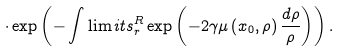<formula> <loc_0><loc_0><loc_500><loc_500>\cdot \exp \left ( - \int \lim i t s _ { r } ^ { R } \exp \left ( - 2 \gamma \mu \left ( x _ { 0 } , \rho \right ) \frac { d \rho } { \rho } \right ) \right ) .</formula> 